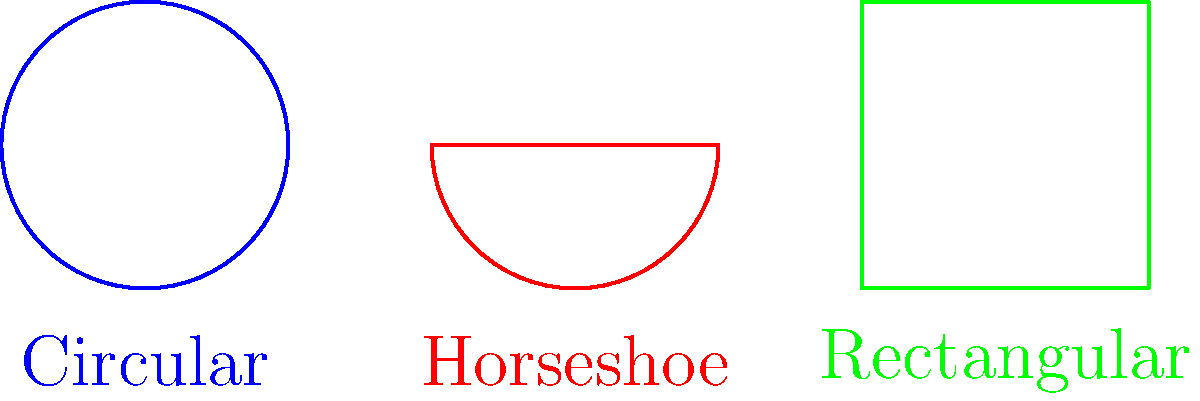As a curator at the Walkerville Museum, you're tasked with comparing the cross-sectional areas of different railroad tunnel shapes. Given that the circular tunnel has a radius of 5 meters, the horseshoe tunnel has a semicircle of radius 5 meters and a height of 7 meters, and the rectangular tunnel is 8 meters wide and 6 meters tall, which tunnel shape has the largest cross-sectional area? Let's calculate the cross-sectional area for each tunnel shape:

1. Circular tunnel:
   Area = $\pi r^2$
   $A_c = \pi (5\text{ m})^2 = 25\pi \text{ m}^2 \approx 78.54 \text{ m}^2$

2. Horseshoe tunnel:
   Area = Area of semicircle + Area of rectangle
   $A_h = \frac{1}{2}\pi r^2 + 2r \times h$
   $A_h = \frac{1}{2}\pi (5\text{ m})^2 + 2(5\text{ m}) \times 2\text{ m}$
   $A_h = \frac{25\pi}{2} \text{ m}^2 + 20 \text{ m}^2$
   $A_h \approx 59.27 \text{ m}^2$

3. Rectangular tunnel:
   Area = width $\times$ height
   $A_r = 8\text{ m} \times 6\text{ m} = 48 \text{ m}^2$

Comparing the results:
Circular: $78.54 \text{ m}^2$
Horseshoe: $59.27 \text{ m}^2$
Rectangular: $48 \text{ m}^2$

The circular tunnel has the largest cross-sectional area.
Answer: Circular tunnel 